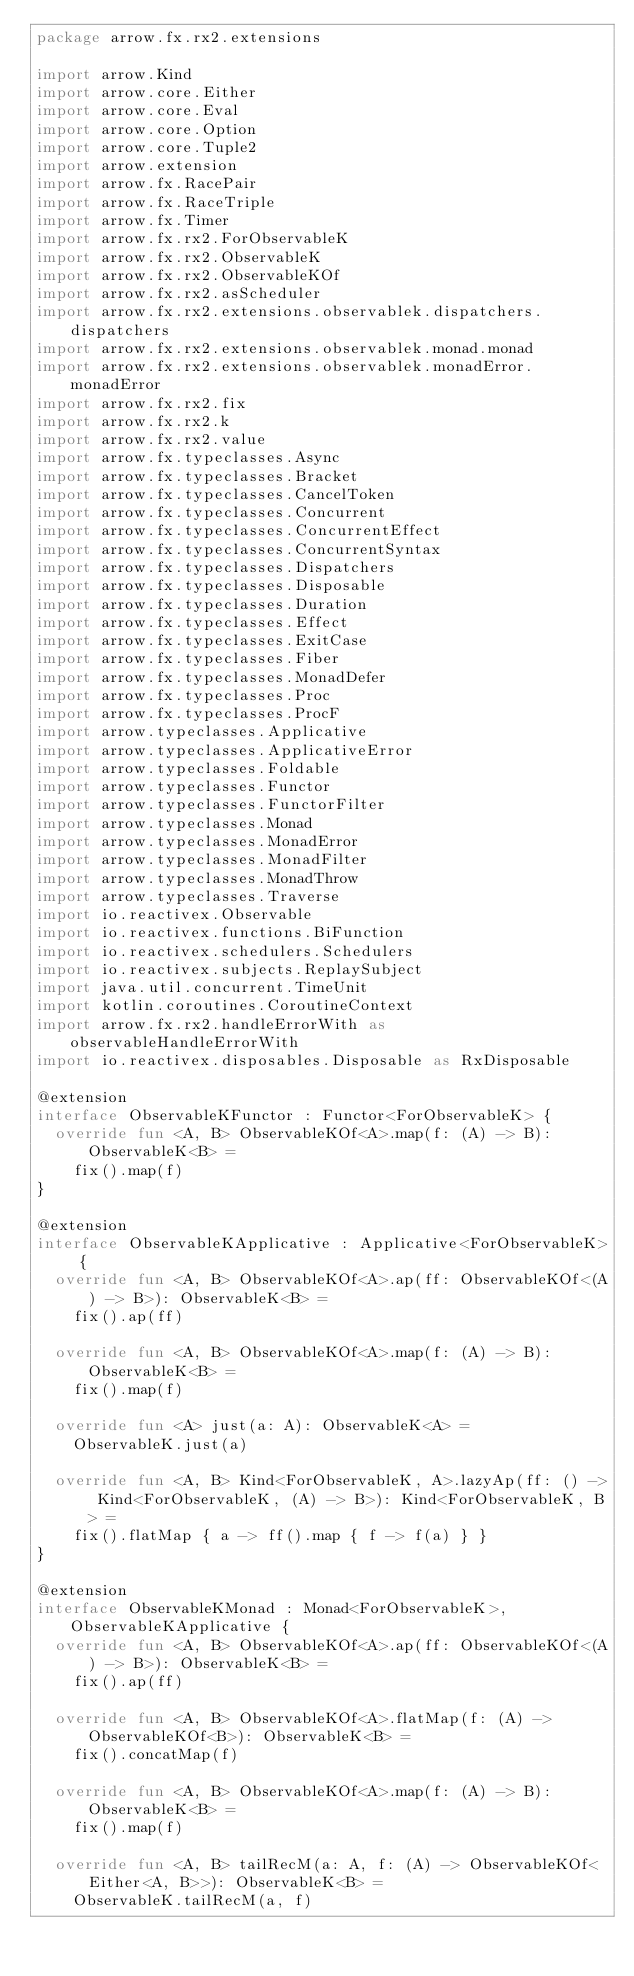Convert code to text. <code><loc_0><loc_0><loc_500><loc_500><_Kotlin_>package arrow.fx.rx2.extensions

import arrow.Kind
import arrow.core.Either
import arrow.core.Eval
import arrow.core.Option
import arrow.core.Tuple2
import arrow.extension
import arrow.fx.RacePair
import arrow.fx.RaceTriple
import arrow.fx.Timer
import arrow.fx.rx2.ForObservableK
import arrow.fx.rx2.ObservableK
import arrow.fx.rx2.ObservableKOf
import arrow.fx.rx2.asScheduler
import arrow.fx.rx2.extensions.observablek.dispatchers.dispatchers
import arrow.fx.rx2.extensions.observablek.monad.monad
import arrow.fx.rx2.extensions.observablek.monadError.monadError
import arrow.fx.rx2.fix
import arrow.fx.rx2.k
import arrow.fx.rx2.value
import arrow.fx.typeclasses.Async
import arrow.fx.typeclasses.Bracket
import arrow.fx.typeclasses.CancelToken
import arrow.fx.typeclasses.Concurrent
import arrow.fx.typeclasses.ConcurrentEffect
import arrow.fx.typeclasses.ConcurrentSyntax
import arrow.fx.typeclasses.Dispatchers
import arrow.fx.typeclasses.Disposable
import arrow.fx.typeclasses.Duration
import arrow.fx.typeclasses.Effect
import arrow.fx.typeclasses.ExitCase
import arrow.fx.typeclasses.Fiber
import arrow.fx.typeclasses.MonadDefer
import arrow.fx.typeclasses.Proc
import arrow.fx.typeclasses.ProcF
import arrow.typeclasses.Applicative
import arrow.typeclasses.ApplicativeError
import arrow.typeclasses.Foldable
import arrow.typeclasses.Functor
import arrow.typeclasses.FunctorFilter
import arrow.typeclasses.Monad
import arrow.typeclasses.MonadError
import arrow.typeclasses.MonadFilter
import arrow.typeclasses.MonadThrow
import arrow.typeclasses.Traverse
import io.reactivex.Observable
import io.reactivex.functions.BiFunction
import io.reactivex.schedulers.Schedulers
import io.reactivex.subjects.ReplaySubject
import java.util.concurrent.TimeUnit
import kotlin.coroutines.CoroutineContext
import arrow.fx.rx2.handleErrorWith as observableHandleErrorWith
import io.reactivex.disposables.Disposable as RxDisposable

@extension
interface ObservableKFunctor : Functor<ForObservableK> {
  override fun <A, B> ObservableKOf<A>.map(f: (A) -> B): ObservableK<B> =
    fix().map(f)
}

@extension
interface ObservableKApplicative : Applicative<ForObservableK> {
  override fun <A, B> ObservableKOf<A>.ap(ff: ObservableKOf<(A) -> B>): ObservableK<B> =
    fix().ap(ff)

  override fun <A, B> ObservableKOf<A>.map(f: (A) -> B): ObservableK<B> =
    fix().map(f)

  override fun <A> just(a: A): ObservableK<A> =
    ObservableK.just(a)

  override fun <A, B> Kind<ForObservableK, A>.lazyAp(ff: () -> Kind<ForObservableK, (A) -> B>): Kind<ForObservableK, B> =
    fix().flatMap { a -> ff().map { f -> f(a) } }
}

@extension
interface ObservableKMonad : Monad<ForObservableK>, ObservableKApplicative {
  override fun <A, B> ObservableKOf<A>.ap(ff: ObservableKOf<(A) -> B>): ObservableK<B> =
    fix().ap(ff)

  override fun <A, B> ObservableKOf<A>.flatMap(f: (A) -> ObservableKOf<B>): ObservableK<B> =
    fix().concatMap(f)

  override fun <A, B> ObservableKOf<A>.map(f: (A) -> B): ObservableK<B> =
    fix().map(f)

  override fun <A, B> tailRecM(a: A, f: (A) -> ObservableKOf<Either<A, B>>): ObservableK<B> =
    ObservableK.tailRecM(a, f)
</code> 